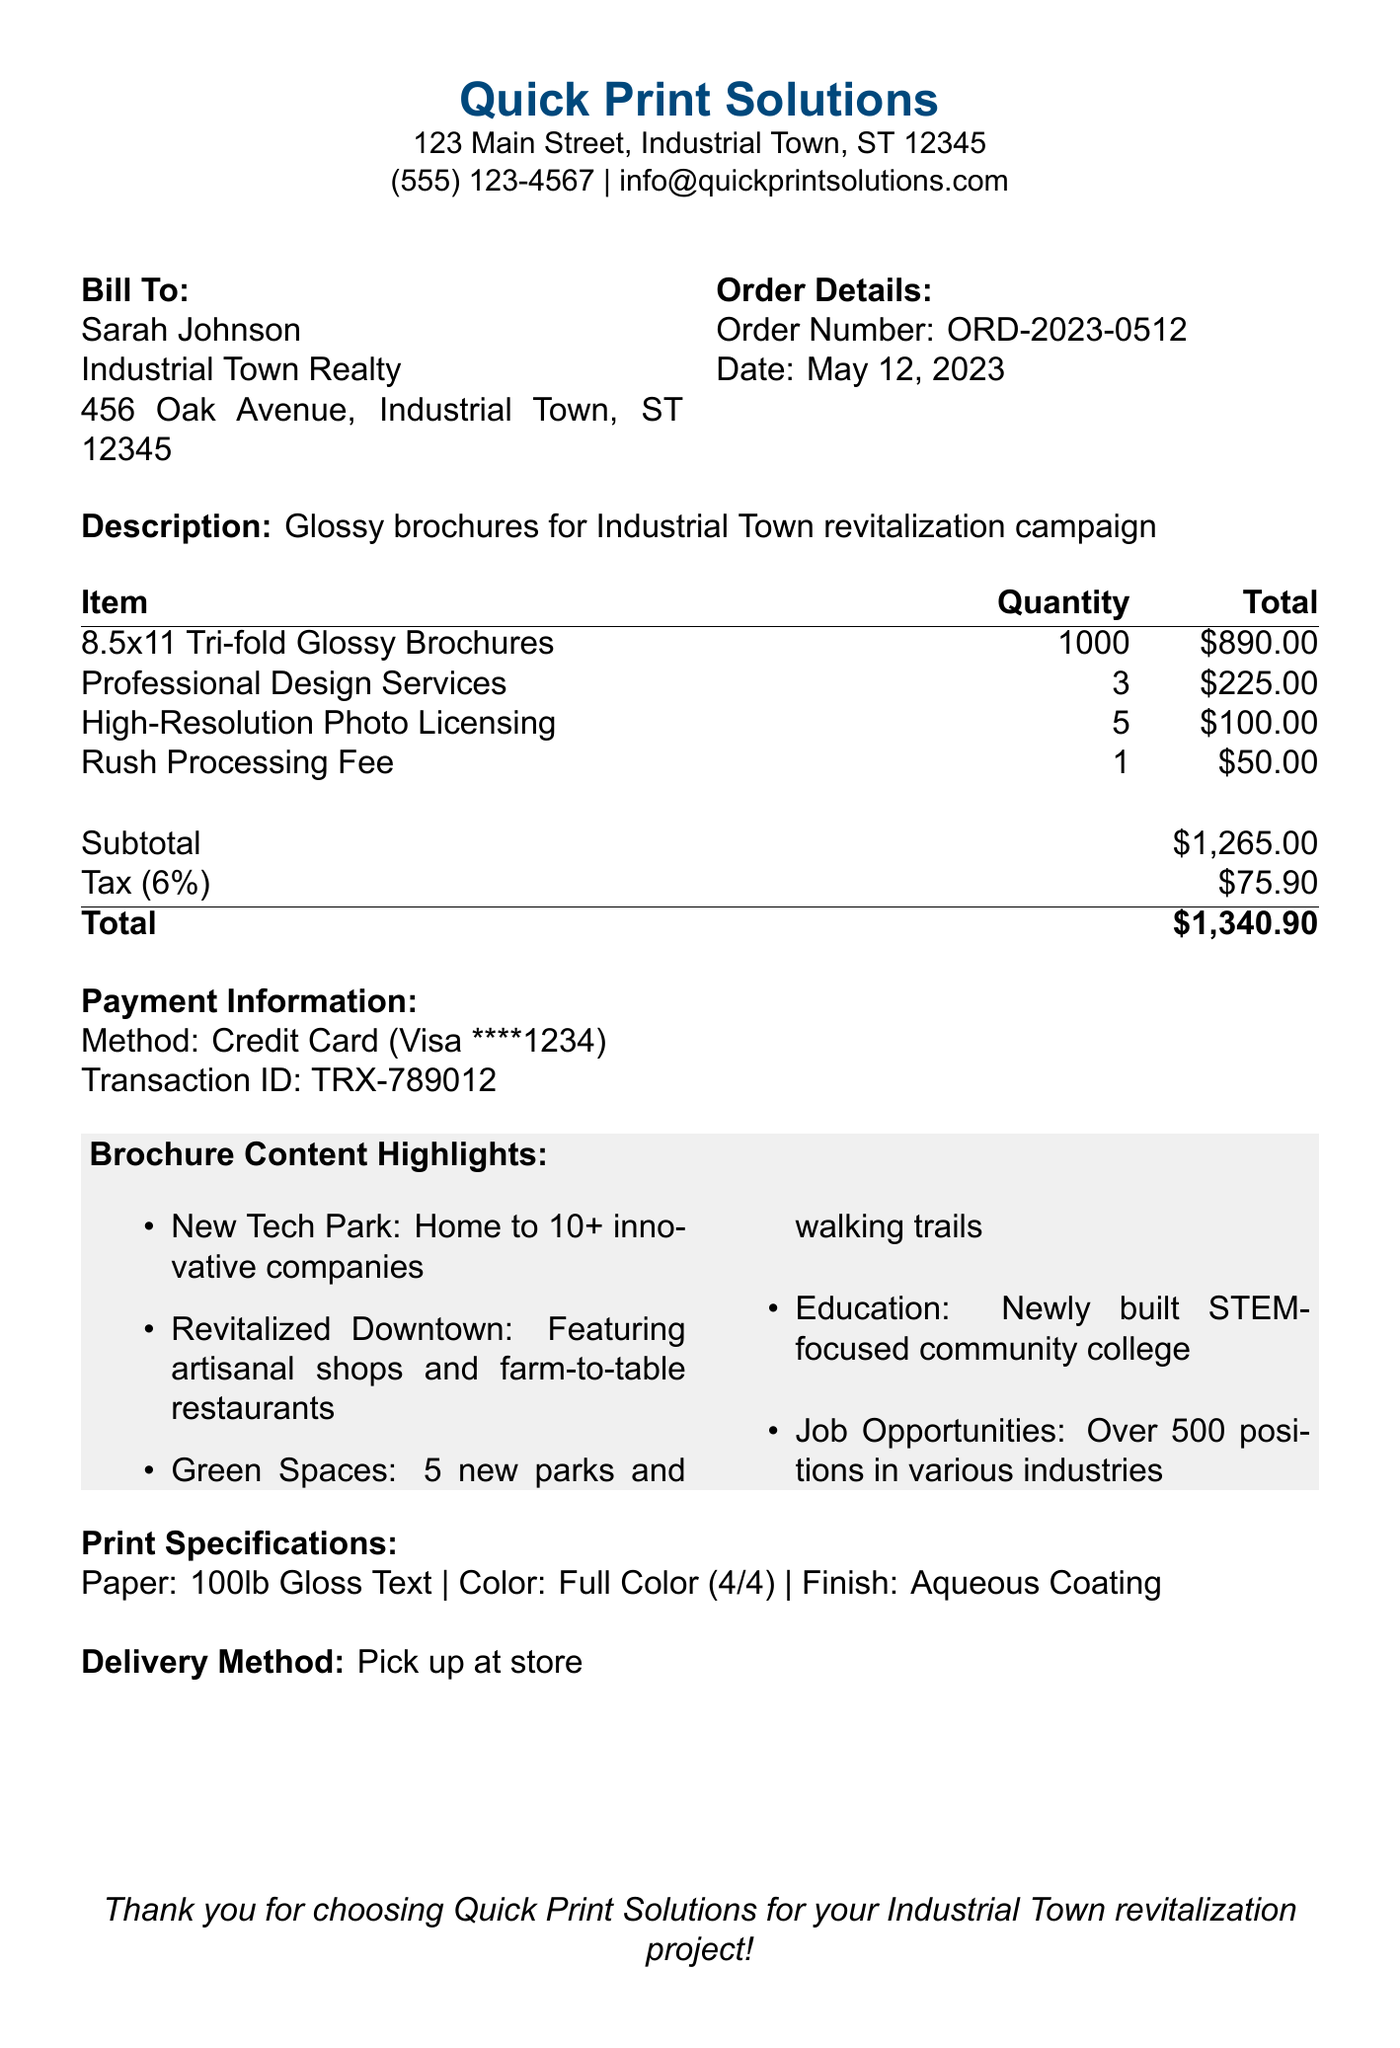What is the business name on the receipt? The business name is provided at the top of the receipt.
Answer: Quick Print Solutions What is the order date? The order date is specified in the order details section.
Answer: May 12, 2023 How many brochures were ordered? The quantity of brochures can be found in the line items section.
Answer: 1000 What is the subtotal amount? The subtotal amount is listed in the totals section of the receipt.
Answer: $1,265.00 What is the total amount including tax? The total amount is shown at the bottom of the totals section.
Answer: $1,340.90 How much were the professional design services? The cost for professional design services is detailed in the line items.
Answer: $225.00 What is the tax rate applied? The tax rate can be found in the totals section of the receipt.
Answer: 6% What is the delivery method for the brochures? The delivery method is mentioned at the end of the receipt.
Answer: Pick up at store What type of payment was used? The payment method is specified in the payment information section.
Answer: Credit Card 